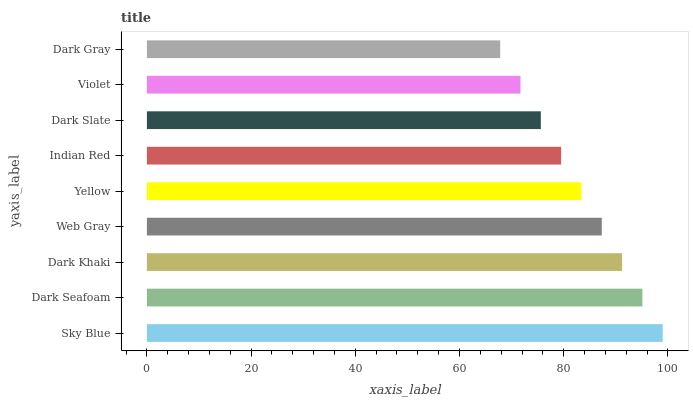Is Dark Gray the minimum?
Answer yes or no. Yes. Is Sky Blue the maximum?
Answer yes or no. Yes. Is Dark Seafoam the minimum?
Answer yes or no. No. Is Dark Seafoam the maximum?
Answer yes or no. No. Is Sky Blue greater than Dark Seafoam?
Answer yes or no. Yes. Is Dark Seafoam less than Sky Blue?
Answer yes or no. Yes. Is Dark Seafoam greater than Sky Blue?
Answer yes or no. No. Is Sky Blue less than Dark Seafoam?
Answer yes or no. No. Is Yellow the high median?
Answer yes or no. Yes. Is Yellow the low median?
Answer yes or no. Yes. Is Dark Gray the high median?
Answer yes or no. No. Is Sky Blue the low median?
Answer yes or no. No. 